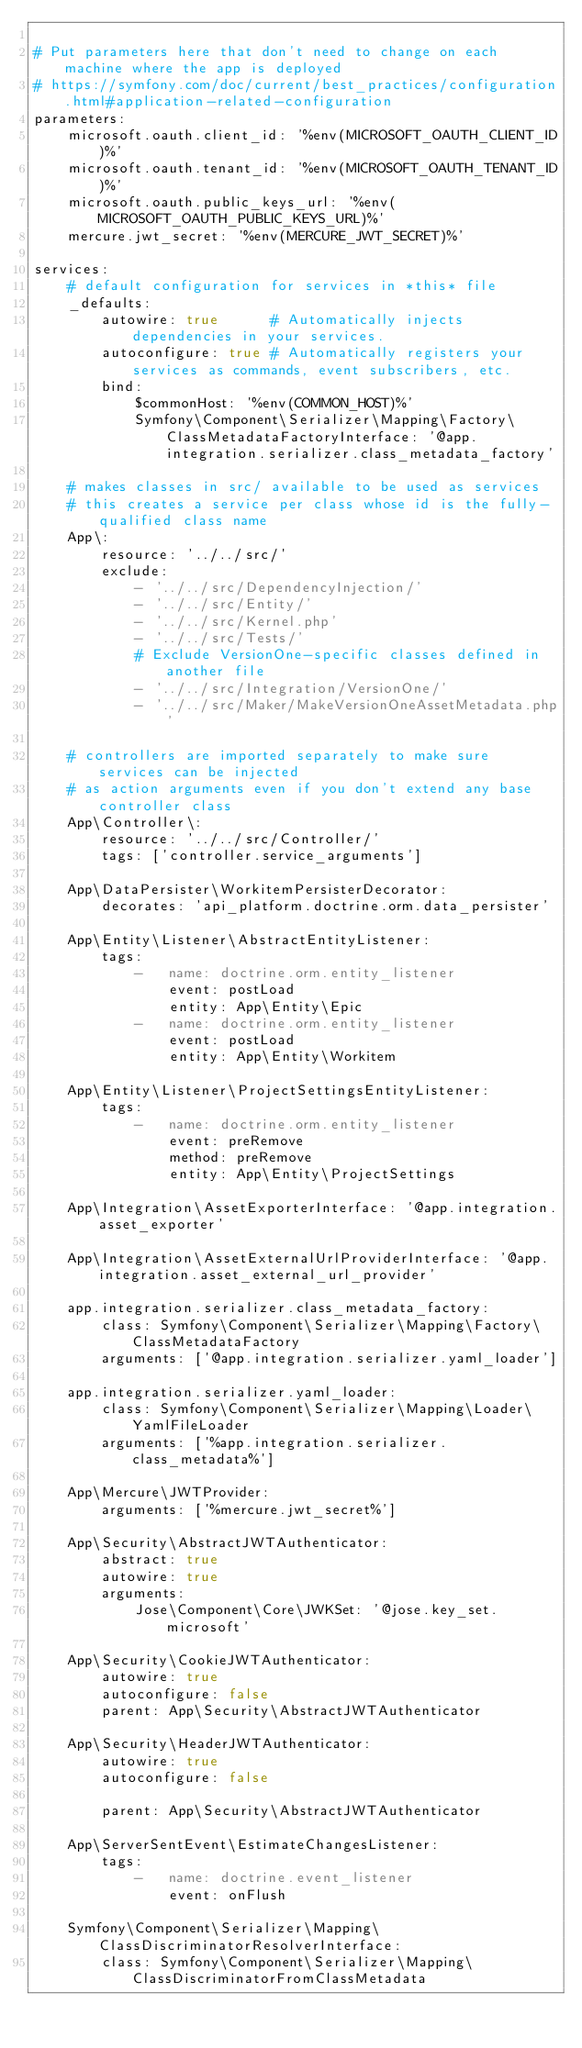Convert code to text. <code><loc_0><loc_0><loc_500><loc_500><_YAML_>
# Put parameters here that don't need to change on each machine where the app is deployed
# https://symfony.com/doc/current/best_practices/configuration.html#application-related-configuration
parameters:
    microsoft.oauth.client_id: '%env(MICROSOFT_OAUTH_CLIENT_ID)%'
    microsoft.oauth.tenant_id: '%env(MICROSOFT_OAUTH_TENANT_ID)%'
    microsoft.oauth.public_keys_url: '%env(MICROSOFT_OAUTH_PUBLIC_KEYS_URL)%'
    mercure.jwt_secret: '%env(MERCURE_JWT_SECRET)%'

services:
    # default configuration for services in *this* file
    _defaults:
        autowire: true      # Automatically injects dependencies in your services.
        autoconfigure: true # Automatically registers your services as commands, event subscribers, etc.
        bind:
            $commonHost: '%env(COMMON_HOST)%'
            Symfony\Component\Serializer\Mapping\Factory\ClassMetadataFactoryInterface: '@app.integration.serializer.class_metadata_factory'

    # makes classes in src/ available to be used as services
    # this creates a service per class whose id is the fully-qualified class name
    App\:
        resource: '../../src/'
        exclude:
            - '../../src/DependencyInjection/'
            - '../../src/Entity/'
            - '../../src/Kernel.php'
            - '../../src/Tests/'
            # Exclude VersionOne-specific classes defined in another file
            - '../../src/Integration/VersionOne/'
            - '../../src/Maker/MakeVersionOneAssetMetadata.php'

    # controllers are imported separately to make sure services can be injected
    # as action arguments even if you don't extend any base controller class
    App\Controller\:
        resource: '../../src/Controller/'
        tags: ['controller.service_arguments']

    App\DataPersister\WorkitemPersisterDecorator:
        decorates: 'api_platform.doctrine.orm.data_persister'

    App\Entity\Listener\AbstractEntityListener:
        tags:
            -   name: doctrine.orm.entity_listener
                event: postLoad
                entity: App\Entity\Epic
            -   name: doctrine.orm.entity_listener
                event: postLoad
                entity: App\Entity\Workitem

    App\Entity\Listener\ProjectSettingsEntityListener:
        tags:
            -   name: doctrine.orm.entity_listener
                event: preRemove
                method: preRemove
                entity: App\Entity\ProjectSettings

    App\Integration\AssetExporterInterface: '@app.integration.asset_exporter'

    App\Integration\AssetExternalUrlProviderInterface: '@app.integration.asset_external_url_provider'

    app.integration.serializer.class_metadata_factory:
        class: Symfony\Component\Serializer\Mapping\Factory\ClassMetadataFactory
        arguments: ['@app.integration.serializer.yaml_loader']

    app.integration.serializer.yaml_loader:
        class: Symfony\Component\Serializer\Mapping\Loader\YamlFileLoader
        arguments: ['%app.integration.serializer.class_metadata%']

    App\Mercure\JWTProvider:
        arguments: ['%mercure.jwt_secret%']

    App\Security\AbstractJWTAuthenticator:
        abstract: true
        autowire: true
        arguments:
            Jose\Component\Core\JWKSet: '@jose.key_set.microsoft'

    App\Security\CookieJWTAuthenticator:
        autowire: true
        autoconfigure: false
        parent: App\Security\AbstractJWTAuthenticator

    App\Security\HeaderJWTAuthenticator:
        autowire: true
        autoconfigure: false

        parent: App\Security\AbstractJWTAuthenticator

    App\ServerSentEvent\EstimateChangesListener:
        tags:
            -   name: doctrine.event_listener
                event: onFlush

    Symfony\Component\Serializer\Mapping\ClassDiscriminatorResolverInterface:
        class: Symfony\Component\Serializer\Mapping\ClassDiscriminatorFromClassMetadata
</code> 